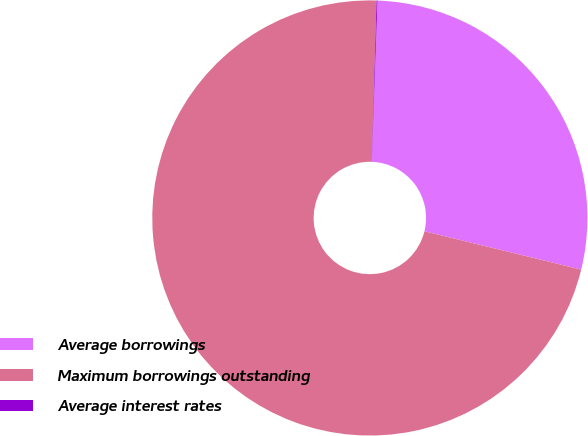Convert chart to OTSL. <chart><loc_0><loc_0><loc_500><loc_500><pie_chart><fcel>Average borrowings<fcel>Maximum borrowings outstanding<fcel>Average interest rates<nl><fcel>28.25%<fcel>71.68%<fcel>0.07%<nl></chart> 